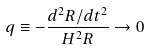<formula> <loc_0><loc_0><loc_500><loc_500>q \equiv - \frac { d ^ { 2 } R / d t ^ { 2 } } { H ^ { 2 } R } \rightarrow 0</formula> 